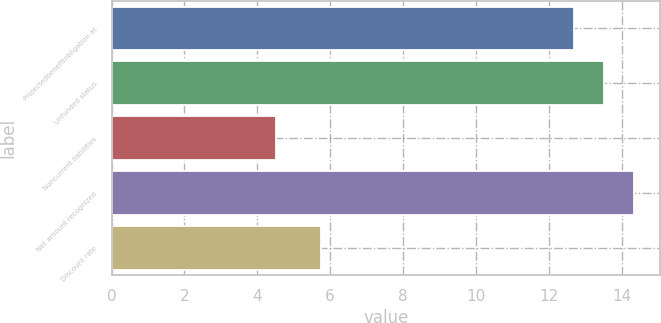<chart> <loc_0><loc_0><loc_500><loc_500><bar_chart><fcel>Projectedbenefitobligation at<fcel>Unfunded status<fcel>Noncurrent liabilities<fcel>Net amount recognized<fcel>Discount rate<nl><fcel>12.7<fcel>13.52<fcel>4.5<fcel>14.34<fcel>5.75<nl></chart> 